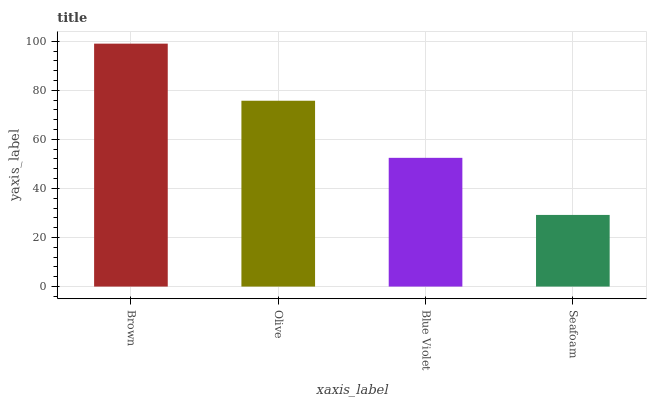Is Seafoam the minimum?
Answer yes or no. Yes. Is Brown the maximum?
Answer yes or no. Yes. Is Olive the minimum?
Answer yes or no. No. Is Olive the maximum?
Answer yes or no. No. Is Brown greater than Olive?
Answer yes or no. Yes. Is Olive less than Brown?
Answer yes or no. Yes. Is Olive greater than Brown?
Answer yes or no. No. Is Brown less than Olive?
Answer yes or no. No. Is Olive the high median?
Answer yes or no. Yes. Is Blue Violet the low median?
Answer yes or no. Yes. Is Seafoam the high median?
Answer yes or no. No. Is Brown the low median?
Answer yes or no. No. 